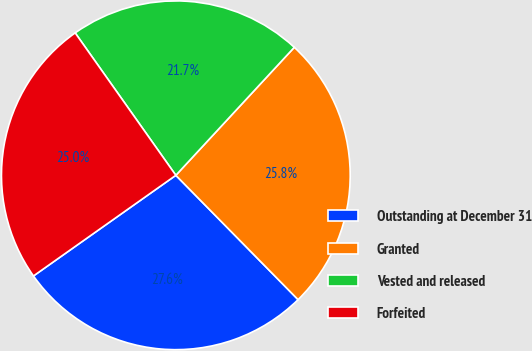Convert chart to OTSL. <chart><loc_0><loc_0><loc_500><loc_500><pie_chart><fcel>Outstanding at December 31<fcel>Granted<fcel>Vested and released<fcel>Forfeited<nl><fcel>27.57%<fcel>25.75%<fcel>21.68%<fcel>25.0%<nl></chart> 